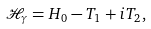<formula> <loc_0><loc_0><loc_500><loc_500>\mathcal { H } _ { \gamma } = H _ { 0 } - T _ { 1 } + i T _ { 2 } ,</formula> 